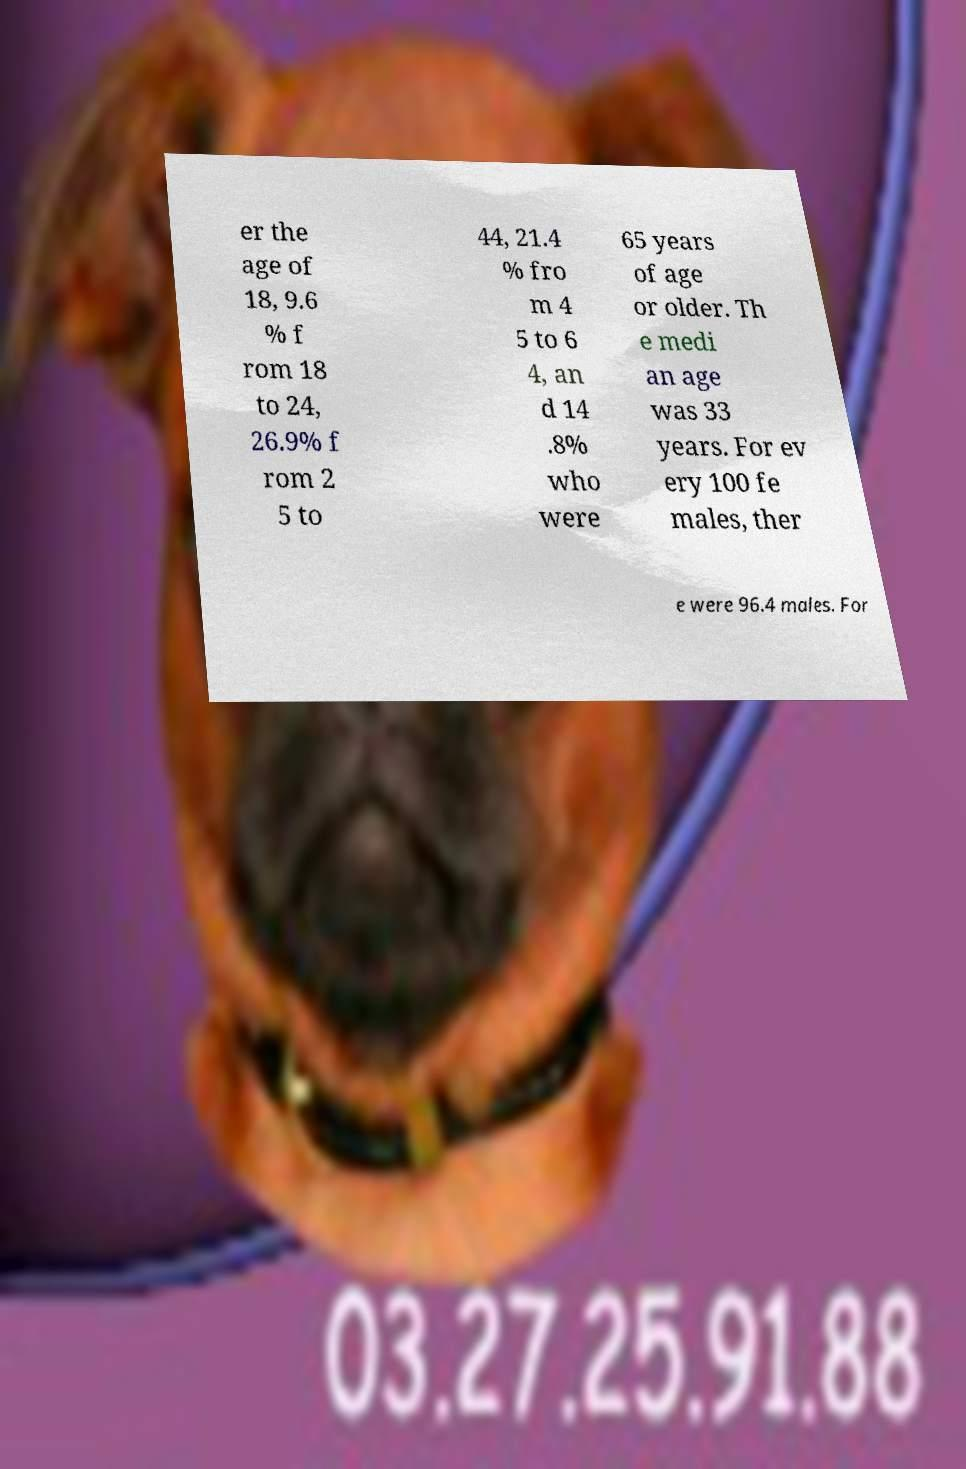Could you extract and type out the text from this image? er the age of 18, 9.6 % f rom 18 to 24, 26.9% f rom 2 5 to 44, 21.4 % fro m 4 5 to 6 4, an d 14 .8% who were 65 years of age or older. Th e medi an age was 33 years. For ev ery 100 fe males, ther e were 96.4 males. For 